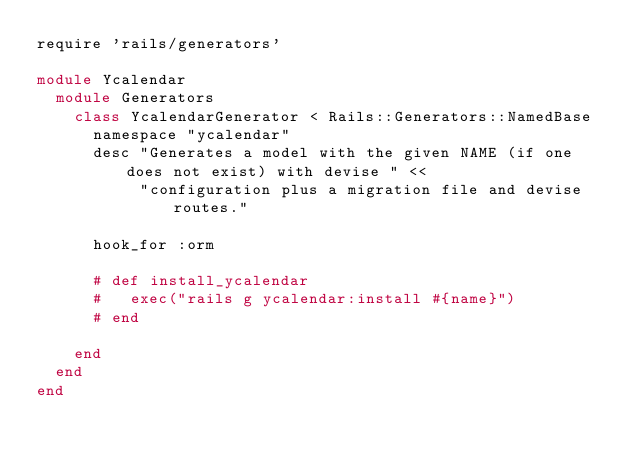Convert code to text. <code><loc_0><loc_0><loc_500><loc_500><_Ruby_>require 'rails/generators'

module Ycalendar
  module Generators
    class YcalendarGenerator < Rails::Generators::NamedBase
      namespace "ycalendar"
      desc "Generates a model with the given NAME (if one does not exist) with devise " <<
           "configuration plus a migration file and devise routes."

      hook_for :orm

      # def install_ycalendar
      #   exec("rails g ycalendar:install #{name}")
      # end

    end
  end
end
</code> 